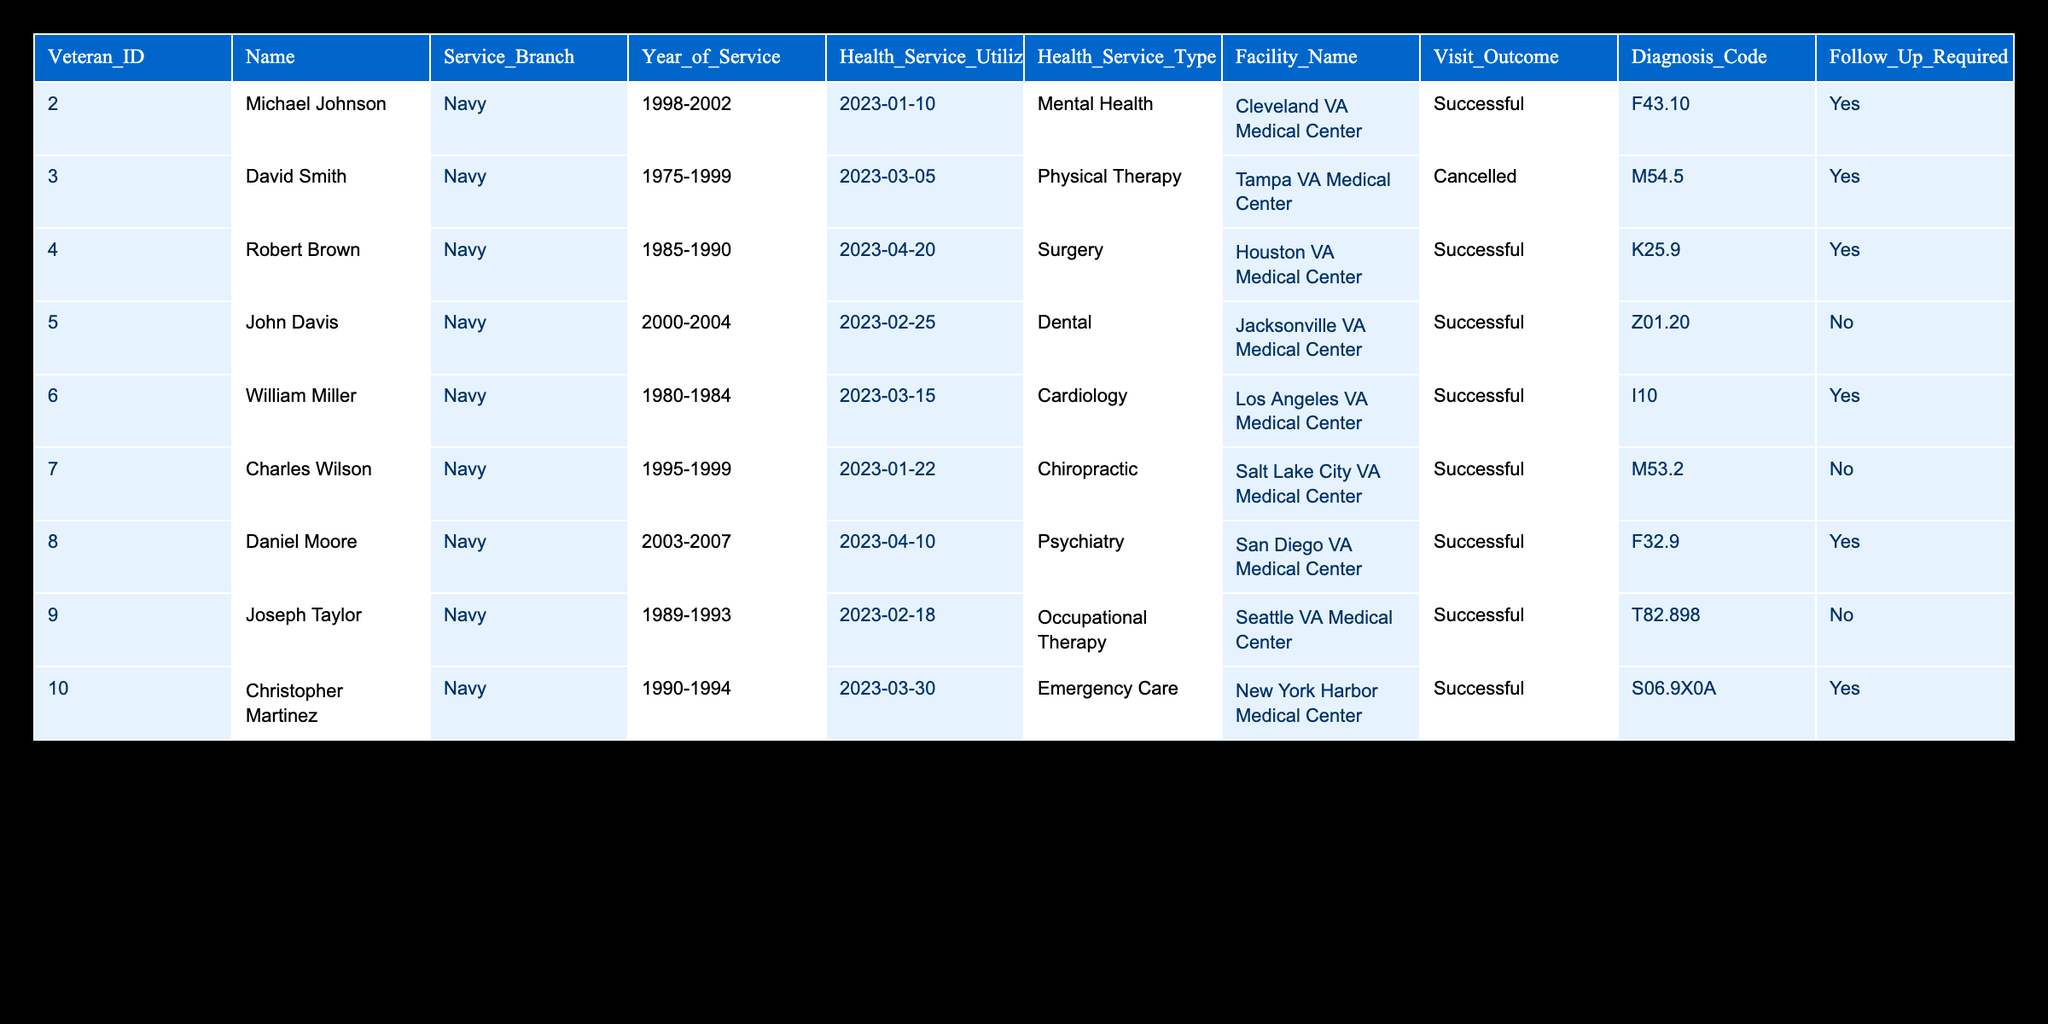What is the diagnosis code for John Davis? According to the table, John Davis has a diagnosis code listed under the Diagnosis_Code column. His name corresponds to the row with a Health_Service_Utilization_Date of 2023-02-25, where the Diagnosis_Code is Z01.20.
Answer: Z01.20 How many veterans had successful visits? To find the number of successful visits, we can count the instances in the Visit_Outcome column where the outcome is marked as "Successful." There are six rows in the table that fall under this category (Michael Johnson, Robert Brown, John Davis, William Miller, Charles Wilson, Daniel Moore, Joseph Taylor, Christopher Martinez). Therefore, the count is 8.
Answer: 8 Was the surgery for Robert Brown successful? The table indicates that Robert Brown's visit outcome is listed under Visit_Outcome as "Successful." Since the answer only requires looking at the outcome for this specific row, it confirms that the surgery was indeed successful.
Answer: Yes What types of health services required follow-up? We need to identify which health service types from the Health_Service_Type column require follow-up. By filtering the Follow_Up_Required column for "Yes," we find that Mental Health, Surgery, Cardiology, Psychiatry, and Emergency Care required follow-ups.
Answer: Mental Health, Surgery, Cardiology, Psychiatry, Emergency Care Which Navy veteran had a cancelled visit and what was the service type? By scanning the table for the Visit_Outcome column, we find that David Smith is the veteran whose visit was cancelled. The corresponding Health_Service_Type is Physical Therapy.
Answer: David Smith, Physical Therapy How many veterans needed follow-up care that utilized the San Diego VA Medical Center? We first filter to find those veterans who had "Yes" marked under Follow_Up_Required and then see which of them used the facility listed in the Facility_Name column as San Diego VA Medical Center. The only veteran that meets these criteria is Daniel Moore, making the count 1.
Answer: 1 Did any veterans utilize the Cleveland VA Medical Center successfully? Looking through the table, there is a veteran named Michael Johnson who utilized the Cleveland VA Medical Center and had a successful visit as indicated in the Visit_Outcome column.
Answer: Yes What is the difference in the number of successful visits versus cancelled visits? Counting from the table, we find there are 8 successful visits and 1 cancelled visit. To determine the difference, we subtract the number of cancelled visits from the successful visits: 8 - 1 = 7. Thus, the difference is 7.
Answer: 7 